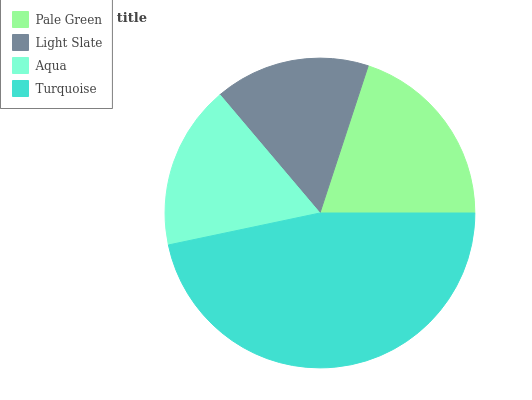Is Light Slate the minimum?
Answer yes or no. Yes. Is Turquoise the maximum?
Answer yes or no. Yes. Is Aqua the minimum?
Answer yes or no. No. Is Aqua the maximum?
Answer yes or no. No. Is Aqua greater than Light Slate?
Answer yes or no. Yes. Is Light Slate less than Aqua?
Answer yes or no. Yes. Is Light Slate greater than Aqua?
Answer yes or no. No. Is Aqua less than Light Slate?
Answer yes or no. No. Is Pale Green the high median?
Answer yes or no. Yes. Is Aqua the low median?
Answer yes or no. Yes. Is Aqua the high median?
Answer yes or no. No. Is Turquoise the low median?
Answer yes or no. No. 